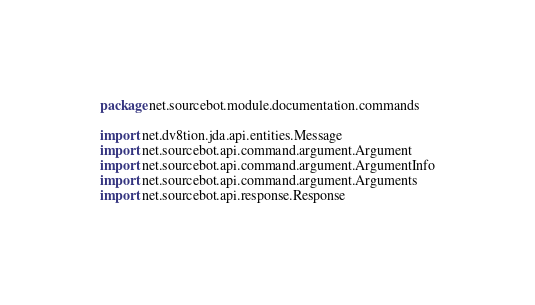<code> <loc_0><loc_0><loc_500><loc_500><_Kotlin_>package net.sourcebot.module.documentation.commands

import net.dv8tion.jda.api.entities.Message
import net.sourcebot.api.command.argument.Argument
import net.sourcebot.api.command.argument.ArgumentInfo
import net.sourcebot.api.command.argument.Arguments
import net.sourcebot.api.response.Response</code> 